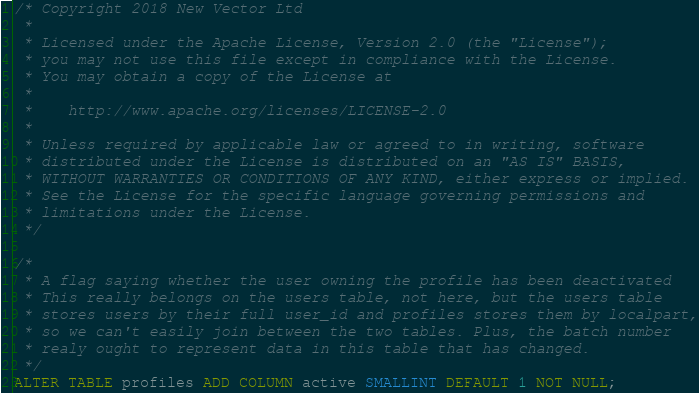Convert code to text. <code><loc_0><loc_0><loc_500><loc_500><_SQL_>/* Copyright 2018 New Vector Ltd
 *
 * Licensed under the Apache License, Version 2.0 (the "License");
 * you may not use this file except in compliance with the License.
 * You may obtain a copy of the License at
 *
 *    http://www.apache.org/licenses/LICENSE-2.0
 *
 * Unless required by applicable law or agreed to in writing, software
 * distributed under the License is distributed on an "AS IS" BASIS,
 * WITHOUT WARRANTIES OR CONDITIONS OF ANY KIND, either express or implied.
 * See the License for the specific language governing permissions and
 * limitations under the License.
 */

/*
 * A flag saying whether the user owning the profile has been deactivated
 * This really belongs on the users table, not here, but the users table
 * stores users by their full user_id and profiles stores them by localpart,
 * so we can't easily join between the two tables. Plus, the batch number
 * realy ought to represent data in this table that has changed.
 */
ALTER TABLE profiles ADD COLUMN active SMALLINT DEFAULT 1 NOT NULL;</code> 